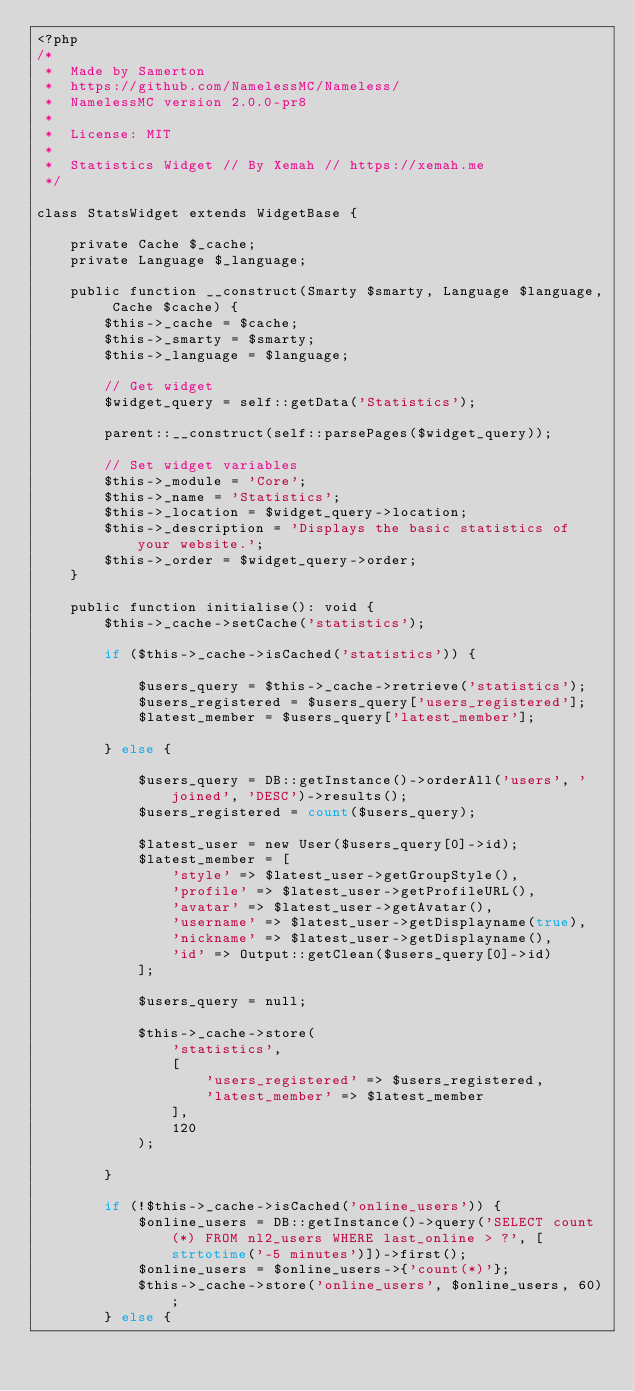<code> <loc_0><loc_0><loc_500><loc_500><_PHP_><?php
/*
 *  Made by Samerton
 *  https://github.com/NamelessMC/Nameless/
 *  NamelessMC version 2.0.0-pr8
 *
 *  License: MIT
 *
 *  Statistics Widget // By Xemah // https://xemah.me
 */

class StatsWidget extends WidgetBase {

    private Cache $_cache;
    private Language $_language;

    public function __construct(Smarty $smarty, Language $language, Cache $cache) {
        $this->_cache = $cache;
        $this->_smarty = $smarty;
        $this->_language = $language;

        // Get widget
        $widget_query = self::getData('Statistics');

        parent::__construct(self::parsePages($widget_query));

        // Set widget variables
        $this->_module = 'Core';
        $this->_name = 'Statistics';
        $this->_location = $widget_query->location;
        $this->_description = 'Displays the basic statistics of your website.';
        $this->_order = $widget_query->order;
    }

    public function initialise(): void {
        $this->_cache->setCache('statistics');

        if ($this->_cache->isCached('statistics')) {

            $users_query = $this->_cache->retrieve('statistics');
            $users_registered = $users_query['users_registered'];
            $latest_member = $users_query['latest_member'];

        } else {

            $users_query = DB::getInstance()->orderAll('users', 'joined', 'DESC')->results();
            $users_registered = count($users_query);

            $latest_user = new User($users_query[0]->id);
            $latest_member = [
                'style' => $latest_user->getGroupStyle(),
                'profile' => $latest_user->getProfileURL(),
                'avatar' => $latest_user->getAvatar(),
                'username' => $latest_user->getDisplayname(true),
                'nickname' => $latest_user->getDisplayname(),
                'id' => Output::getClean($users_query[0]->id)
            ];

            $users_query = null;

            $this->_cache->store(
                'statistics',
                [
                    'users_registered' => $users_registered,
                    'latest_member' => $latest_member
                ],
                120
            );

        }

        if (!$this->_cache->isCached('online_users')) {
            $online_users = DB::getInstance()->query('SELECT count(*) FROM nl2_users WHERE last_online > ?', [strtotime('-5 minutes')])->first();
            $online_users = $online_users->{'count(*)'};
            $this->_cache->store('online_users', $online_users, 60);
        } else {</code> 